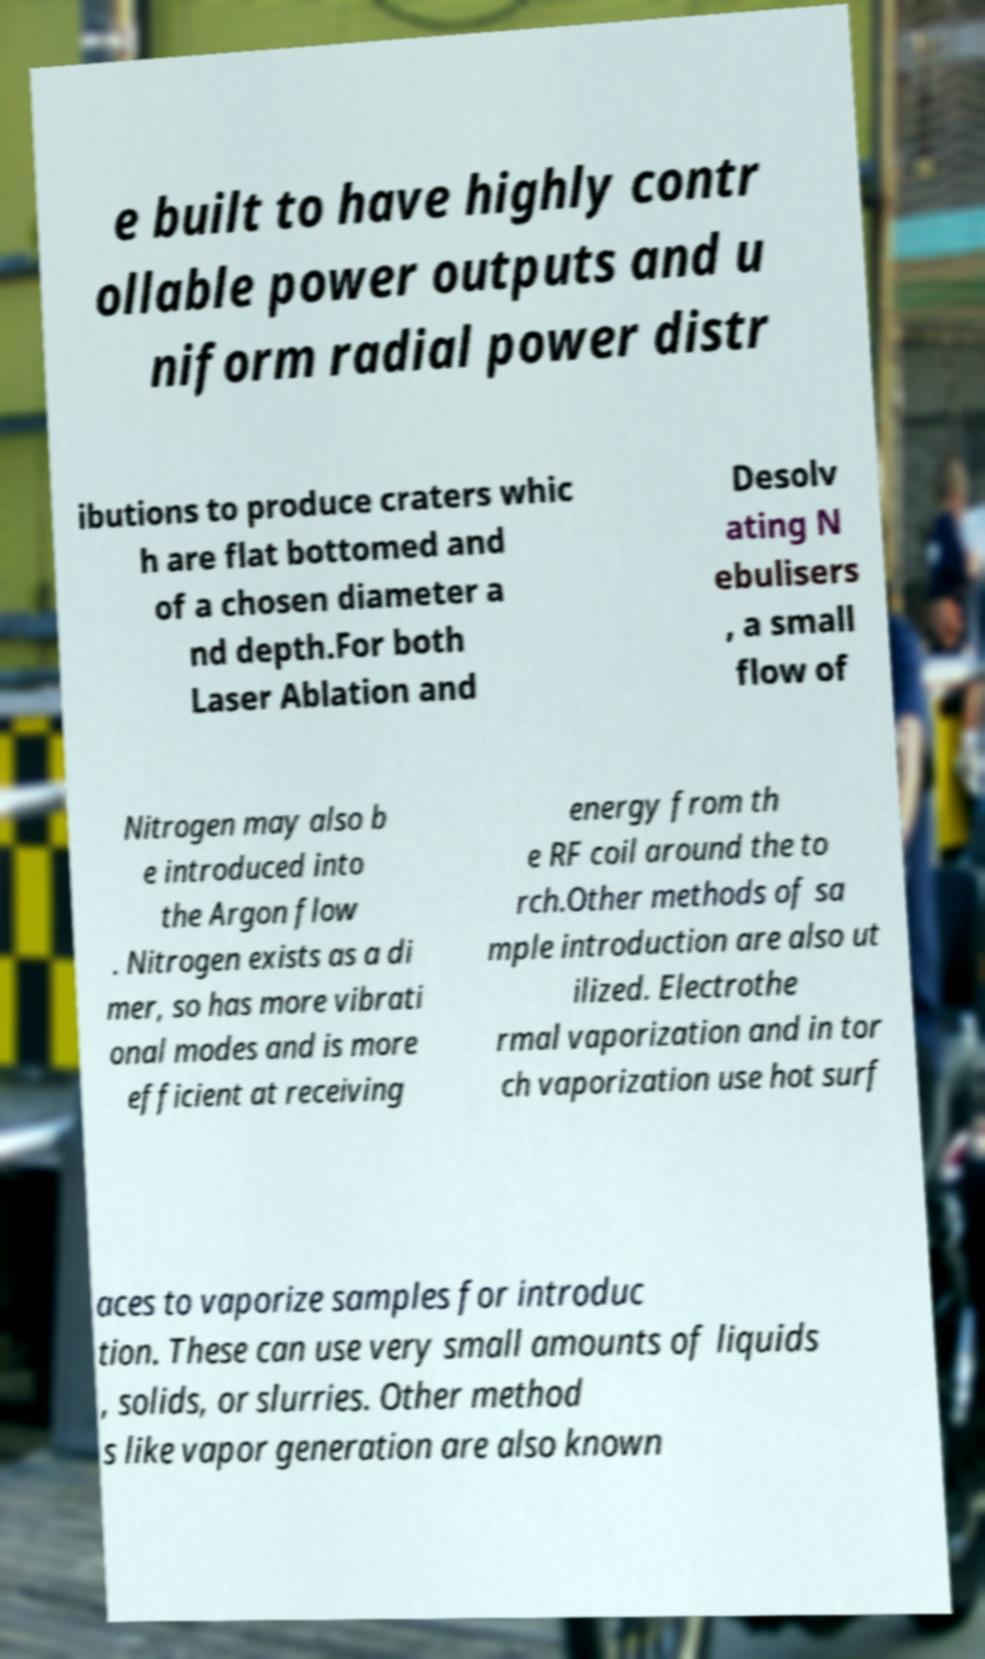Can you read and provide the text displayed in the image?This photo seems to have some interesting text. Can you extract and type it out for me? e built to have highly contr ollable power outputs and u niform radial power distr ibutions to produce craters whic h are flat bottomed and of a chosen diameter a nd depth.For both Laser Ablation and Desolv ating N ebulisers , a small flow of Nitrogen may also b e introduced into the Argon flow . Nitrogen exists as a di mer, so has more vibrati onal modes and is more efficient at receiving energy from th e RF coil around the to rch.Other methods of sa mple introduction are also ut ilized. Electrothe rmal vaporization and in tor ch vaporization use hot surf aces to vaporize samples for introduc tion. These can use very small amounts of liquids , solids, or slurries. Other method s like vapor generation are also known 